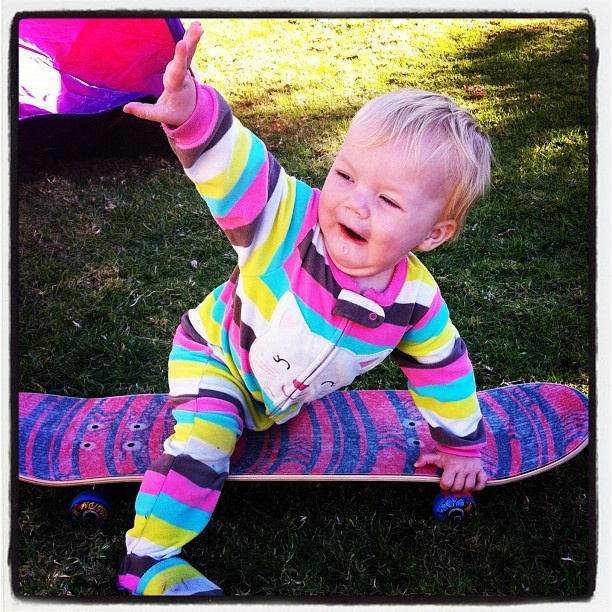Describe the objects in this image and their specific colors. I can see people in white, lavender, black, pink, and lightpink tones and skateboard in white, black, darkblue, and purple tones in this image. 